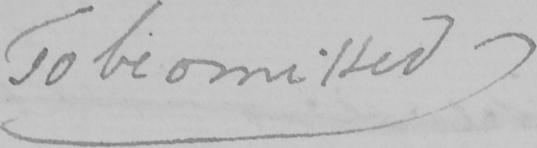What is written in this line of handwriting? To be omitted 